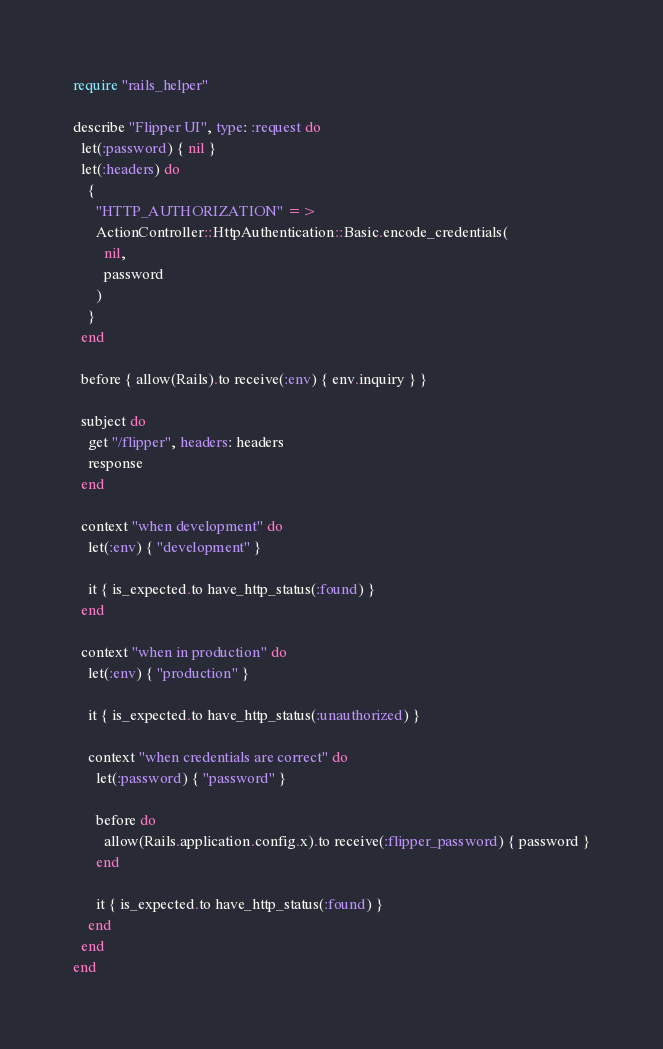<code> <loc_0><loc_0><loc_500><loc_500><_Ruby_>require "rails_helper"

describe "Flipper UI", type: :request do
  let(:password) { nil }
  let(:headers) do
    {
      "HTTP_AUTHORIZATION" =>
      ActionController::HttpAuthentication::Basic.encode_credentials(
        nil,
        password
      )
    }
  end

  before { allow(Rails).to receive(:env) { env.inquiry } }

  subject do
    get "/flipper", headers: headers
    response
  end

  context "when development" do
    let(:env) { "development" }

    it { is_expected.to have_http_status(:found) }
  end

  context "when in production" do
    let(:env) { "production" }

    it { is_expected.to have_http_status(:unauthorized) }

    context "when credentials are correct" do
      let(:password) { "password" }

      before do
        allow(Rails.application.config.x).to receive(:flipper_password) { password }
      end

      it { is_expected.to have_http_status(:found) }
    end
  end
end
</code> 